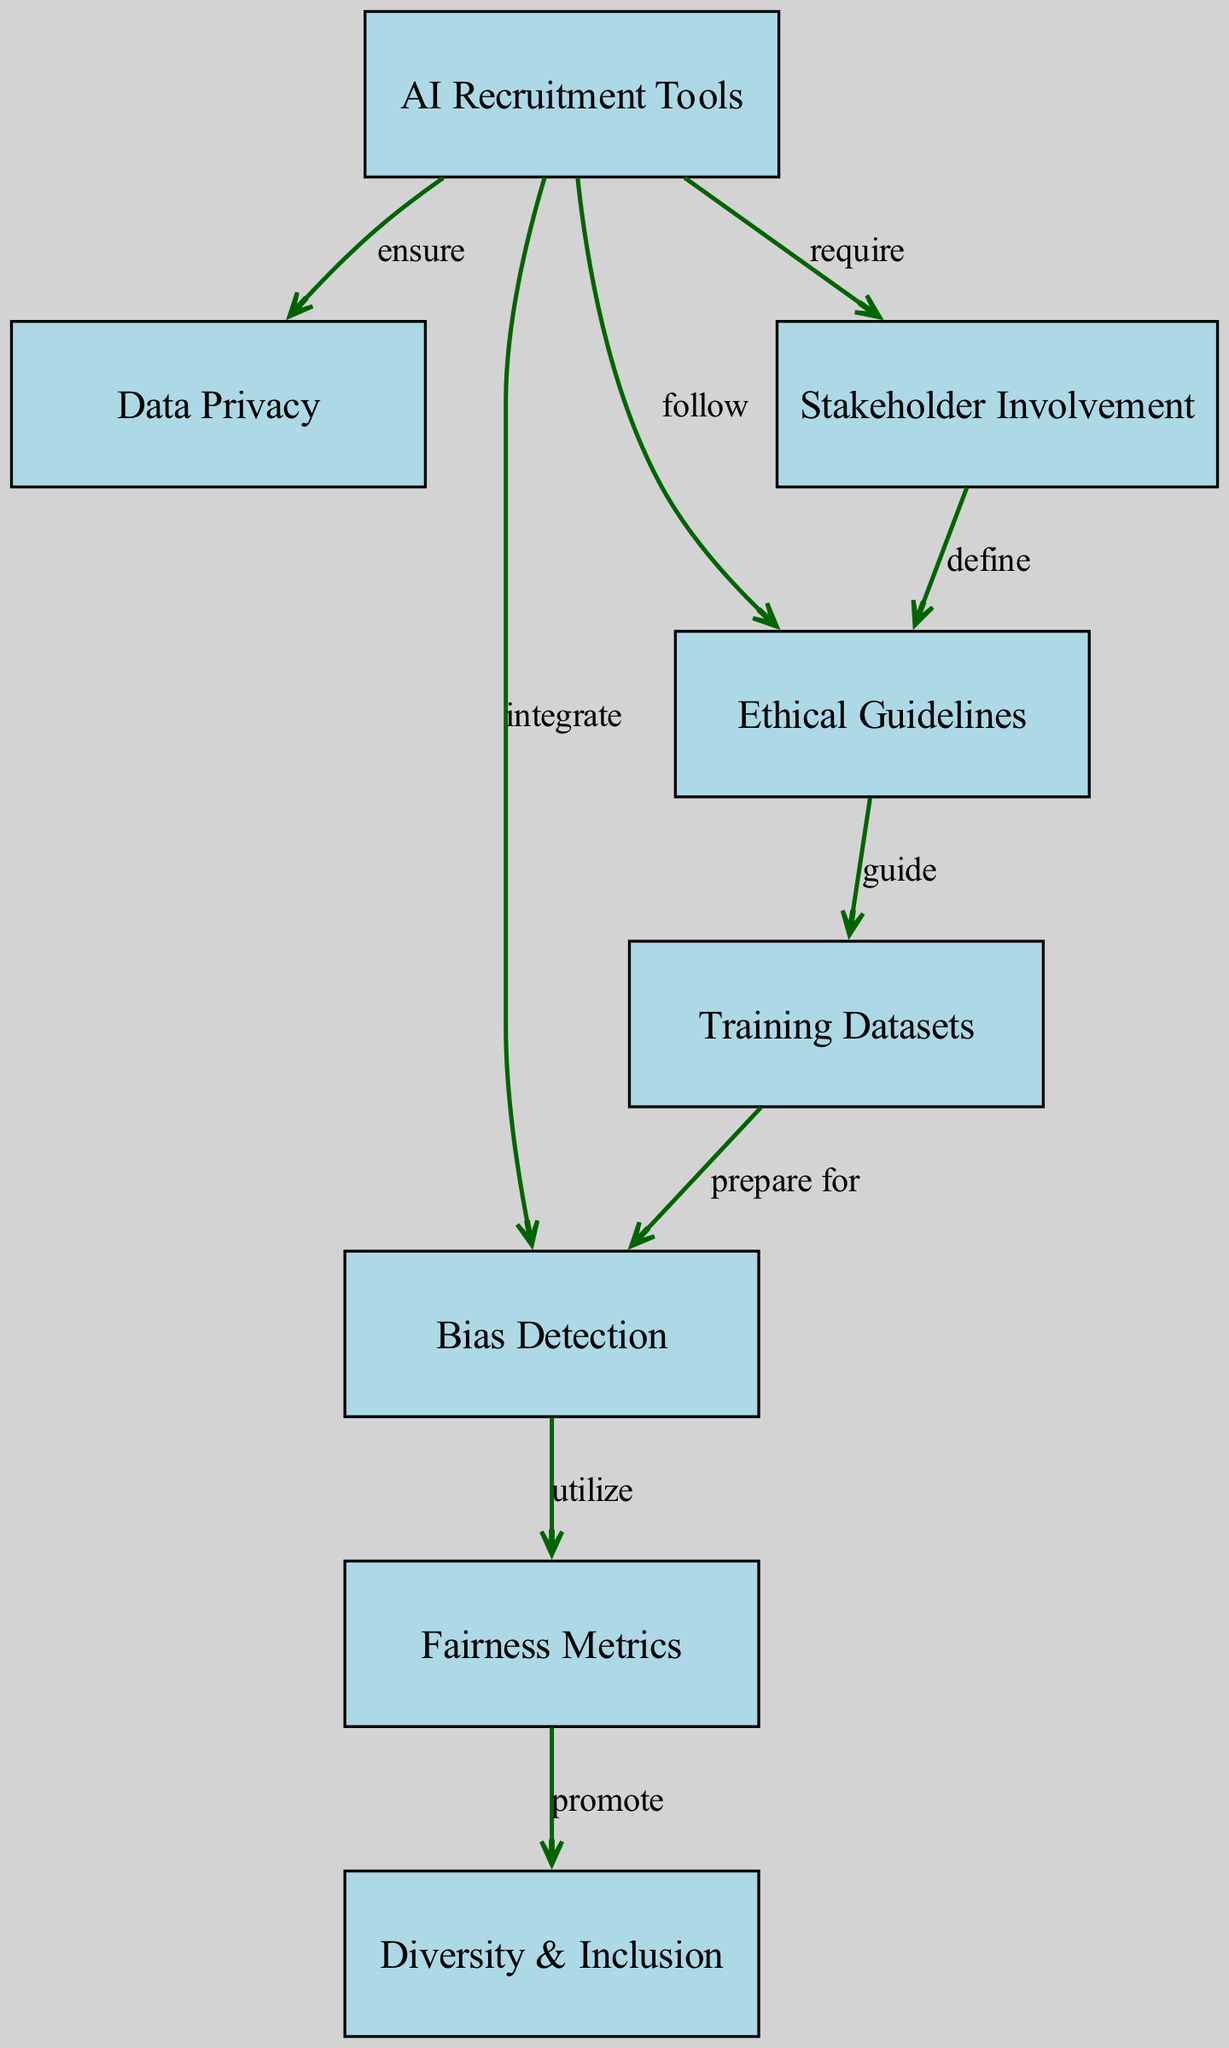What is the main subject of the diagram? The diagram centers around AI Recruitment Tools, which serve as the primary node. This information can be found in the label of the main node of the diagram.
Answer: AI Recruitment Tools How many nodes are present in the diagram? By counting each individual node listed in the data, there are eight unique nodes related to different aspects of ethical considerations in AI recruitment tools.
Answer: 8 Which node is connected to "Bias Detection"? Following the edges in the diagram, "Bias Detection" is connected to both "AI Recruitment Tools" (which integrates it) and "Fairness Metrics" (which utilizes it). The first connection indicates it is directly linked to "AI Recruitment Tools."
Answer: AI Recruitment Tools What type of guidelines guide training datasets? The edge labeled "guide" from "Ethical Guidelines" to "Training Datasets" identifies that ethical guidelines are the type of guidelines that govern how training datasets should be curated.
Answer: Ethical Guidelines What is a consequence of utilizing fairness metrics? The diagram shows that utilizing fairness metrics promotes "Diversity & Inclusion," indicating that they serve the purpose of enhancing diversity and inclusion in hiring practices through better assessment of fairness.
Answer: Diversity & Inclusion What is the relationship between stakeholder involvement and ethical guidelines? "Stakeholder Involvement" defines "Ethical Guidelines," suggesting that the engagement of various stakeholders in the AI recruitment process helps to set the standards and practices that ensure ethical AI use.
Answer: define Which two nodes can be tracked from "Bias Detection"? Examining the edges, "Bias Detection" has connections leading to "Fairness Metrics" (utilize) and "Training Datasets" (prepare for). This indicates that both fairness metrics and training datasets are directly related to bias detection processes.
Answer: Fairness Metrics and Training Datasets Which node requires stakeholder involvement? The edge labeled "require" connecting "AI Recruitment Tools" to "Stakeholder Involvement" indicates that stakeholder involvement is a necessary component for AI recruitment tools to function effectively.
Answer: Stakeholder Involvement 